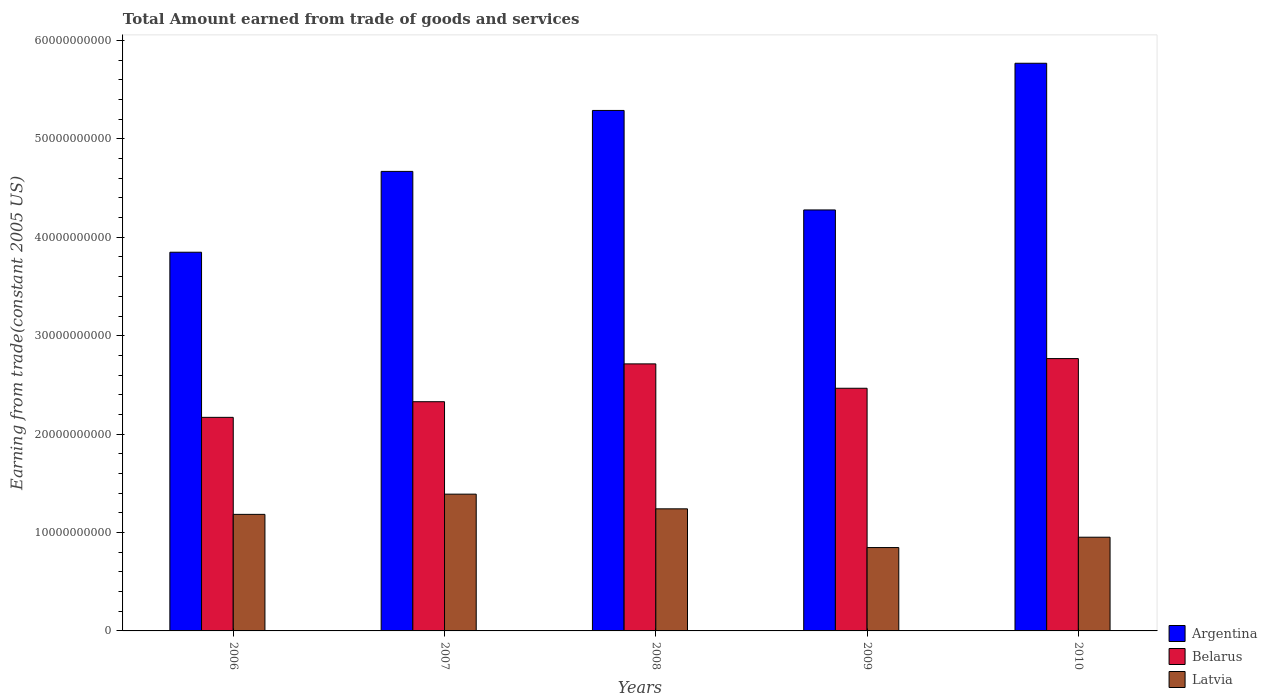How many different coloured bars are there?
Your response must be concise. 3. Are the number of bars on each tick of the X-axis equal?
Your answer should be compact. Yes. How many bars are there on the 4th tick from the right?
Keep it short and to the point. 3. What is the label of the 3rd group of bars from the left?
Offer a very short reply. 2008. In how many cases, is the number of bars for a given year not equal to the number of legend labels?
Ensure brevity in your answer.  0. What is the total amount earned by trading goods and services in Belarus in 2009?
Give a very brief answer. 2.47e+1. Across all years, what is the maximum total amount earned by trading goods and services in Latvia?
Provide a succinct answer. 1.39e+1. Across all years, what is the minimum total amount earned by trading goods and services in Latvia?
Give a very brief answer. 8.47e+09. In which year was the total amount earned by trading goods and services in Argentina maximum?
Keep it short and to the point. 2010. In which year was the total amount earned by trading goods and services in Latvia minimum?
Your answer should be compact. 2009. What is the total total amount earned by trading goods and services in Latvia in the graph?
Your response must be concise. 5.61e+1. What is the difference between the total amount earned by trading goods and services in Latvia in 2007 and that in 2010?
Keep it short and to the point. 4.37e+09. What is the difference between the total amount earned by trading goods and services in Argentina in 2010 and the total amount earned by trading goods and services in Belarus in 2009?
Keep it short and to the point. 3.30e+1. What is the average total amount earned by trading goods and services in Argentina per year?
Your answer should be very brief. 4.77e+1. In the year 2008, what is the difference between the total amount earned by trading goods and services in Argentina and total amount earned by trading goods and services in Belarus?
Your answer should be compact. 2.58e+1. What is the ratio of the total amount earned by trading goods and services in Belarus in 2007 to that in 2008?
Provide a short and direct response. 0.86. Is the total amount earned by trading goods and services in Belarus in 2009 less than that in 2010?
Provide a short and direct response. Yes. What is the difference between the highest and the second highest total amount earned by trading goods and services in Belarus?
Give a very brief answer. 5.39e+08. What is the difference between the highest and the lowest total amount earned by trading goods and services in Argentina?
Offer a very short reply. 1.92e+1. What does the 1st bar from the left in 2008 represents?
Give a very brief answer. Argentina. Is it the case that in every year, the sum of the total amount earned by trading goods and services in Belarus and total amount earned by trading goods and services in Latvia is greater than the total amount earned by trading goods and services in Argentina?
Keep it short and to the point. No. Are all the bars in the graph horizontal?
Your answer should be compact. No. How many years are there in the graph?
Keep it short and to the point. 5. Are the values on the major ticks of Y-axis written in scientific E-notation?
Your response must be concise. No. Does the graph contain any zero values?
Keep it short and to the point. No. Does the graph contain grids?
Your answer should be compact. No. Where does the legend appear in the graph?
Offer a terse response. Bottom right. How many legend labels are there?
Your answer should be compact. 3. How are the legend labels stacked?
Your response must be concise. Vertical. What is the title of the graph?
Your response must be concise. Total Amount earned from trade of goods and services. Does "Singapore" appear as one of the legend labels in the graph?
Ensure brevity in your answer.  No. What is the label or title of the Y-axis?
Provide a succinct answer. Earning from trade(constant 2005 US). What is the Earning from trade(constant 2005 US) in Argentina in 2006?
Provide a succinct answer. 3.85e+1. What is the Earning from trade(constant 2005 US) in Belarus in 2006?
Your answer should be very brief. 2.17e+1. What is the Earning from trade(constant 2005 US) of Latvia in 2006?
Offer a terse response. 1.18e+1. What is the Earning from trade(constant 2005 US) of Argentina in 2007?
Give a very brief answer. 4.67e+1. What is the Earning from trade(constant 2005 US) of Belarus in 2007?
Provide a short and direct response. 2.33e+1. What is the Earning from trade(constant 2005 US) of Latvia in 2007?
Keep it short and to the point. 1.39e+1. What is the Earning from trade(constant 2005 US) in Argentina in 2008?
Ensure brevity in your answer.  5.29e+1. What is the Earning from trade(constant 2005 US) in Belarus in 2008?
Your response must be concise. 2.71e+1. What is the Earning from trade(constant 2005 US) in Latvia in 2008?
Provide a succinct answer. 1.24e+1. What is the Earning from trade(constant 2005 US) of Argentina in 2009?
Your answer should be very brief. 4.28e+1. What is the Earning from trade(constant 2005 US) of Belarus in 2009?
Provide a short and direct response. 2.47e+1. What is the Earning from trade(constant 2005 US) in Latvia in 2009?
Your answer should be very brief. 8.47e+09. What is the Earning from trade(constant 2005 US) in Argentina in 2010?
Give a very brief answer. 5.77e+1. What is the Earning from trade(constant 2005 US) of Belarus in 2010?
Provide a succinct answer. 2.77e+1. What is the Earning from trade(constant 2005 US) in Latvia in 2010?
Provide a short and direct response. 9.52e+09. Across all years, what is the maximum Earning from trade(constant 2005 US) in Argentina?
Keep it short and to the point. 5.77e+1. Across all years, what is the maximum Earning from trade(constant 2005 US) of Belarus?
Offer a very short reply. 2.77e+1. Across all years, what is the maximum Earning from trade(constant 2005 US) in Latvia?
Provide a short and direct response. 1.39e+1. Across all years, what is the minimum Earning from trade(constant 2005 US) in Argentina?
Give a very brief answer. 3.85e+1. Across all years, what is the minimum Earning from trade(constant 2005 US) of Belarus?
Offer a terse response. 2.17e+1. Across all years, what is the minimum Earning from trade(constant 2005 US) of Latvia?
Offer a very short reply. 8.47e+09. What is the total Earning from trade(constant 2005 US) of Argentina in the graph?
Provide a short and direct response. 2.39e+11. What is the total Earning from trade(constant 2005 US) in Belarus in the graph?
Provide a short and direct response. 1.24e+11. What is the total Earning from trade(constant 2005 US) in Latvia in the graph?
Your response must be concise. 5.61e+1. What is the difference between the Earning from trade(constant 2005 US) of Argentina in 2006 and that in 2007?
Keep it short and to the point. -8.21e+09. What is the difference between the Earning from trade(constant 2005 US) in Belarus in 2006 and that in 2007?
Provide a succinct answer. -1.59e+09. What is the difference between the Earning from trade(constant 2005 US) in Latvia in 2006 and that in 2007?
Keep it short and to the point. -2.05e+09. What is the difference between the Earning from trade(constant 2005 US) of Argentina in 2006 and that in 2008?
Provide a short and direct response. -1.44e+1. What is the difference between the Earning from trade(constant 2005 US) of Belarus in 2006 and that in 2008?
Your answer should be very brief. -5.43e+09. What is the difference between the Earning from trade(constant 2005 US) in Latvia in 2006 and that in 2008?
Your response must be concise. -5.63e+08. What is the difference between the Earning from trade(constant 2005 US) in Argentina in 2006 and that in 2009?
Ensure brevity in your answer.  -4.30e+09. What is the difference between the Earning from trade(constant 2005 US) in Belarus in 2006 and that in 2009?
Ensure brevity in your answer.  -2.96e+09. What is the difference between the Earning from trade(constant 2005 US) of Latvia in 2006 and that in 2009?
Your response must be concise. 3.37e+09. What is the difference between the Earning from trade(constant 2005 US) in Argentina in 2006 and that in 2010?
Your answer should be compact. -1.92e+1. What is the difference between the Earning from trade(constant 2005 US) of Belarus in 2006 and that in 2010?
Your answer should be compact. -5.97e+09. What is the difference between the Earning from trade(constant 2005 US) of Latvia in 2006 and that in 2010?
Provide a short and direct response. 2.32e+09. What is the difference between the Earning from trade(constant 2005 US) of Argentina in 2007 and that in 2008?
Provide a succinct answer. -6.19e+09. What is the difference between the Earning from trade(constant 2005 US) of Belarus in 2007 and that in 2008?
Your answer should be compact. -3.84e+09. What is the difference between the Earning from trade(constant 2005 US) of Latvia in 2007 and that in 2008?
Your answer should be compact. 1.49e+09. What is the difference between the Earning from trade(constant 2005 US) in Argentina in 2007 and that in 2009?
Provide a short and direct response. 3.92e+09. What is the difference between the Earning from trade(constant 2005 US) in Belarus in 2007 and that in 2009?
Make the answer very short. -1.37e+09. What is the difference between the Earning from trade(constant 2005 US) in Latvia in 2007 and that in 2009?
Provide a short and direct response. 5.43e+09. What is the difference between the Earning from trade(constant 2005 US) of Argentina in 2007 and that in 2010?
Keep it short and to the point. -1.10e+1. What is the difference between the Earning from trade(constant 2005 US) in Belarus in 2007 and that in 2010?
Offer a very short reply. -4.38e+09. What is the difference between the Earning from trade(constant 2005 US) in Latvia in 2007 and that in 2010?
Make the answer very short. 4.37e+09. What is the difference between the Earning from trade(constant 2005 US) of Argentina in 2008 and that in 2009?
Ensure brevity in your answer.  1.01e+1. What is the difference between the Earning from trade(constant 2005 US) in Belarus in 2008 and that in 2009?
Provide a succinct answer. 2.48e+09. What is the difference between the Earning from trade(constant 2005 US) in Latvia in 2008 and that in 2009?
Provide a short and direct response. 3.93e+09. What is the difference between the Earning from trade(constant 2005 US) of Argentina in 2008 and that in 2010?
Your answer should be compact. -4.80e+09. What is the difference between the Earning from trade(constant 2005 US) of Belarus in 2008 and that in 2010?
Keep it short and to the point. -5.39e+08. What is the difference between the Earning from trade(constant 2005 US) in Latvia in 2008 and that in 2010?
Provide a short and direct response. 2.88e+09. What is the difference between the Earning from trade(constant 2005 US) in Argentina in 2009 and that in 2010?
Keep it short and to the point. -1.49e+1. What is the difference between the Earning from trade(constant 2005 US) of Belarus in 2009 and that in 2010?
Provide a succinct answer. -3.01e+09. What is the difference between the Earning from trade(constant 2005 US) of Latvia in 2009 and that in 2010?
Offer a very short reply. -1.05e+09. What is the difference between the Earning from trade(constant 2005 US) of Argentina in 2006 and the Earning from trade(constant 2005 US) of Belarus in 2007?
Keep it short and to the point. 1.52e+1. What is the difference between the Earning from trade(constant 2005 US) of Argentina in 2006 and the Earning from trade(constant 2005 US) of Latvia in 2007?
Your answer should be very brief. 2.46e+1. What is the difference between the Earning from trade(constant 2005 US) in Belarus in 2006 and the Earning from trade(constant 2005 US) in Latvia in 2007?
Ensure brevity in your answer.  7.80e+09. What is the difference between the Earning from trade(constant 2005 US) of Argentina in 2006 and the Earning from trade(constant 2005 US) of Belarus in 2008?
Your answer should be compact. 1.13e+1. What is the difference between the Earning from trade(constant 2005 US) of Argentina in 2006 and the Earning from trade(constant 2005 US) of Latvia in 2008?
Your answer should be very brief. 2.61e+1. What is the difference between the Earning from trade(constant 2005 US) of Belarus in 2006 and the Earning from trade(constant 2005 US) of Latvia in 2008?
Ensure brevity in your answer.  9.30e+09. What is the difference between the Earning from trade(constant 2005 US) of Argentina in 2006 and the Earning from trade(constant 2005 US) of Belarus in 2009?
Your response must be concise. 1.38e+1. What is the difference between the Earning from trade(constant 2005 US) of Argentina in 2006 and the Earning from trade(constant 2005 US) of Latvia in 2009?
Offer a very short reply. 3.00e+1. What is the difference between the Earning from trade(constant 2005 US) in Belarus in 2006 and the Earning from trade(constant 2005 US) in Latvia in 2009?
Your answer should be very brief. 1.32e+1. What is the difference between the Earning from trade(constant 2005 US) in Argentina in 2006 and the Earning from trade(constant 2005 US) in Belarus in 2010?
Your answer should be very brief. 1.08e+1. What is the difference between the Earning from trade(constant 2005 US) in Argentina in 2006 and the Earning from trade(constant 2005 US) in Latvia in 2010?
Offer a very short reply. 2.90e+1. What is the difference between the Earning from trade(constant 2005 US) of Belarus in 2006 and the Earning from trade(constant 2005 US) of Latvia in 2010?
Your response must be concise. 1.22e+1. What is the difference between the Earning from trade(constant 2005 US) of Argentina in 2007 and the Earning from trade(constant 2005 US) of Belarus in 2008?
Give a very brief answer. 1.96e+1. What is the difference between the Earning from trade(constant 2005 US) in Argentina in 2007 and the Earning from trade(constant 2005 US) in Latvia in 2008?
Offer a terse response. 3.43e+1. What is the difference between the Earning from trade(constant 2005 US) in Belarus in 2007 and the Earning from trade(constant 2005 US) in Latvia in 2008?
Make the answer very short. 1.09e+1. What is the difference between the Earning from trade(constant 2005 US) of Argentina in 2007 and the Earning from trade(constant 2005 US) of Belarus in 2009?
Make the answer very short. 2.20e+1. What is the difference between the Earning from trade(constant 2005 US) of Argentina in 2007 and the Earning from trade(constant 2005 US) of Latvia in 2009?
Provide a succinct answer. 3.82e+1. What is the difference between the Earning from trade(constant 2005 US) of Belarus in 2007 and the Earning from trade(constant 2005 US) of Latvia in 2009?
Offer a terse response. 1.48e+1. What is the difference between the Earning from trade(constant 2005 US) of Argentina in 2007 and the Earning from trade(constant 2005 US) of Belarus in 2010?
Your answer should be very brief. 1.90e+1. What is the difference between the Earning from trade(constant 2005 US) in Argentina in 2007 and the Earning from trade(constant 2005 US) in Latvia in 2010?
Make the answer very short. 3.72e+1. What is the difference between the Earning from trade(constant 2005 US) in Belarus in 2007 and the Earning from trade(constant 2005 US) in Latvia in 2010?
Keep it short and to the point. 1.38e+1. What is the difference between the Earning from trade(constant 2005 US) of Argentina in 2008 and the Earning from trade(constant 2005 US) of Belarus in 2009?
Keep it short and to the point. 2.82e+1. What is the difference between the Earning from trade(constant 2005 US) in Argentina in 2008 and the Earning from trade(constant 2005 US) in Latvia in 2009?
Provide a succinct answer. 4.44e+1. What is the difference between the Earning from trade(constant 2005 US) in Belarus in 2008 and the Earning from trade(constant 2005 US) in Latvia in 2009?
Keep it short and to the point. 1.87e+1. What is the difference between the Earning from trade(constant 2005 US) in Argentina in 2008 and the Earning from trade(constant 2005 US) in Belarus in 2010?
Keep it short and to the point. 2.52e+1. What is the difference between the Earning from trade(constant 2005 US) in Argentina in 2008 and the Earning from trade(constant 2005 US) in Latvia in 2010?
Your answer should be very brief. 4.34e+1. What is the difference between the Earning from trade(constant 2005 US) of Belarus in 2008 and the Earning from trade(constant 2005 US) of Latvia in 2010?
Provide a short and direct response. 1.76e+1. What is the difference between the Earning from trade(constant 2005 US) in Argentina in 2009 and the Earning from trade(constant 2005 US) in Belarus in 2010?
Provide a short and direct response. 1.51e+1. What is the difference between the Earning from trade(constant 2005 US) of Argentina in 2009 and the Earning from trade(constant 2005 US) of Latvia in 2010?
Your response must be concise. 3.33e+1. What is the difference between the Earning from trade(constant 2005 US) of Belarus in 2009 and the Earning from trade(constant 2005 US) of Latvia in 2010?
Provide a short and direct response. 1.51e+1. What is the average Earning from trade(constant 2005 US) of Argentina per year?
Ensure brevity in your answer.  4.77e+1. What is the average Earning from trade(constant 2005 US) in Belarus per year?
Keep it short and to the point. 2.49e+1. What is the average Earning from trade(constant 2005 US) of Latvia per year?
Provide a succinct answer. 1.12e+1. In the year 2006, what is the difference between the Earning from trade(constant 2005 US) in Argentina and Earning from trade(constant 2005 US) in Belarus?
Offer a very short reply. 1.68e+1. In the year 2006, what is the difference between the Earning from trade(constant 2005 US) of Argentina and Earning from trade(constant 2005 US) of Latvia?
Your answer should be very brief. 2.66e+1. In the year 2006, what is the difference between the Earning from trade(constant 2005 US) of Belarus and Earning from trade(constant 2005 US) of Latvia?
Provide a succinct answer. 9.86e+09. In the year 2007, what is the difference between the Earning from trade(constant 2005 US) in Argentina and Earning from trade(constant 2005 US) in Belarus?
Your answer should be very brief. 2.34e+1. In the year 2007, what is the difference between the Earning from trade(constant 2005 US) in Argentina and Earning from trade(constant 2005 US) in Latvia?
Offer a very short reply. 3.28e+1. In the year 2007, what is the difference between the Earning from trade(constant 2005 US) of Belarus and Earning from trade(constant 2005 US) of Latvia?
Offer a very short reply. 9.39e+09. In the year 2008, what is the difference between the Earning from trade(constant 2005 US) in Argentina and Earning from trade(constant 2005 US) in Belarus?
Offer a terse response. 2.58e+1. In the year 2008, what is the difference between the Earning from trade(constant 2005 US) in Argentina and Earning from trade(constant 2005 US) in Latvia?
Offer a very short reply. 4.05e+1. In the year 2008, what is the difference between the Earning from trade(constant 2005 US) in Belarus and Earning from trade(constant 2005 US) in Latvia?
Your response must be concise. 1.47e+1. In the year 2009, what is the difference between the Earning from trade(constant 2005 US) in Argentina and Earning from trade(constant 2005 US) in Belarus?
Your answer should be very brief. 1.81e+1. In the year 2009, what is the difference between the Earning from trade(constant 2005 US) of Argentina and Earning from trade(constant 2005 US) of Latvia?
Make the answer very short. 3.43e+1. In the year 2009, what is the difference between the Earning from trade(constant 2005 US) in Belarus and Earning from trade(constant 2005 US) in Latvia?
Your answer should be very brief. 1.62e+1. In the year 2010, what is the difference between the Earning from trade(constant 2005 US) of Argentina and Earning from trade(constant 2005 US) of Belarus?
Give a very brief answer. 3.00e+1. In the year 2010, what is the difference between the Earning from trade(constant 2005 US) of Argentina and Earning from trade(constant 2005 US) of Latvia?
Give a very brief answer. 4.82e+1. In the year 2010, what is the difference between the Earning from trade(constant 2005 US) of Belarus and Earning from trade(constant 2005 US) of Latvia?
Ensure brevity in your answer.  1.82e+1. What is the ratio of the Earning from trade(constant 2005 US) of Argentina in 2006 to that in 2007?
Make the answer very short. 0.82. What is the ratio of the Earning from trade(constant 2005 US) in Belarus in 2006 to that in 2007?
Provide a succinct answer. 0.93. What is the ratio of the Earning from trade(constant 2005 US) in Latvia in 2006 to that in 2007?
Offer a very short reply. 0.85. What is the ratio of the Earning from trade(constant 2005 US) in Argentina in 2006 to that in 2008?
Your response must be concise. 0.73. What is the ratio of the Earning from trade(constant 2005 US) of Belarus in 2006 to that in 2008?
Provide a succinct answer. 0.8. What is the ratio of the Earning from trade(constant 2005 US) of Latvia in 2006 to that in 2008?
Provide a short and direct response. 0.95. What is the ratio of the Earning from trade(constant 2005 US) of Argentina in 2006 to that in 2009?
Keep it short and to the point. 0.9. What is the ratio of the Earning from trade(constant 2005 US) in Belarus in 2006 to that in 2009?
Give a very brief answer. 0.88. What is the ratio of the Earning from trade(constant 2005 US) in Latvia in 2006 to that in 2009?
Your answer should be very brief. 1.4. What is the ratio of the Earning from trade(constant 2005 US) of Argentina in 2006 to that in 2010?
Offer a terse response. 0.67. What is the ratio of the Earning from trade(constant 2005 US) in Belarus in 2006 to that in 2010?
Your response must be concise. 0.78. What is the ratio of the Earning from trade(constant 2005 US) of Latvia in 2006 to that in 2010?
Make the answer very short. 1.24. What is the ratio of the Earning from trade(constant 2005 US) of Argentina in 2007 to that in 2008?
Keep it short and to the point. 0.88. What is the ratio of the Earning from trade(constant 2005 US) in Belarus in 2007 to that in 2008?
Your answer should be very brief. 0.86. What is the ratio of the Earning from trade(constant 2005 US) of Latvia in 2007 to that in 2008?
Your answer should be very brief. 1.12. What is the ratio of the Earning from trade(constant 2005 US) in Argentina in 2007 to that in 2009?
Give a very brief answer. 1.09. What is the ratio of the Earning from trade(constant 2005 US) of Belarus in 2007 to that in 2009?
Your answer should be compact. 0.94. What is the ratio of the Earning from trade(constant 2005 US) in Latvia in 2007 to that in 2009?
Your answer should be compact. 1.64. What is the ratio of the Earning from trade(constant 2005 US) in Argentina in 2007 to that in 2010?
Give a very brief answer. 0.81. What is the ratio of the Earning from trade(constant 2005 US) of Belarus in 2007 to that in 2010?
Ensure brevity in your answer.  0.84. What is the ratio of the Earning from trade(constant 2005 US) in Latvia in 2007 to that in 2010?
Ensure brevity in your answer.  1.46. What is the ratio of the Earning from trade(constant 2005 US) of Argentina in 2008 to that in 2009?
Offer a terse response. 1.24. What is the ratio of the Earning from trade(constant 2005 US) in Belarus in 2008 to that in 2009?
Keep it short and to the point. 1.1. What is the ratio of the Earning from trade(constant 2005 US) of Latvia in 2008 to that in 2009?
Your answer should be very brief. 1.46. What is the ratio of the Earning from trade(constant 2005 US) of Argentina in 2008 to that in 2010?
Offer a very short reply. 0.92. What is the ratio of the Earning from trade(constant 2005 US) in Belarus in 2008 to that in 2010?
Make the answer very short. 0.98. What is the ratio of the Earning from trade(constant 2005 US) in Latvia in 2008 to that in 2010?
Make the answer very short. 1.3. What is the ratio of the Earning from trade(constant 2005 US) of Argentina in 2009 to that in 2010?
Offer a very short reply. 0.74. What is the ratio of the Earning from trade(constant 2005 US) in Belarus in 2009 to that in 2010?
Make the answer very short. 0.89. What is the ratio of the Earning from trade(constant 2005 US) in Latvia in 2009 to that in 2010?
Make the answer very short. 0.89. What is the difference between the highest and the second highest Earning from trade(constant 2005 US) of Argentina?
Offer a terse response. 4.80e+09. What is the difference between the highest and the second highest Earning from trade(constant 2005 US) of Belarus?
Offer a terse response. 5.39e+08. What is the difference between the highest and the second highest Earning from trade(constant 2005 US) of Latvia?
Make the answer very short. 1.49e+09. What is the difference between the highest and the lowest Earning from trade(constant 2005 US) of Argentina?
Keep it short and to the point. 1.92e+1. What is the difference between the highest and the lowest Earning from trade(constant 2005 US) in Belarus?
Your answer should be very brief. 5.97e+09. What is the difference between the highest and the lowest Earning from trade(constant 2005 US) in Latvia?
Your answer should be very brief. 5.43e+09. 